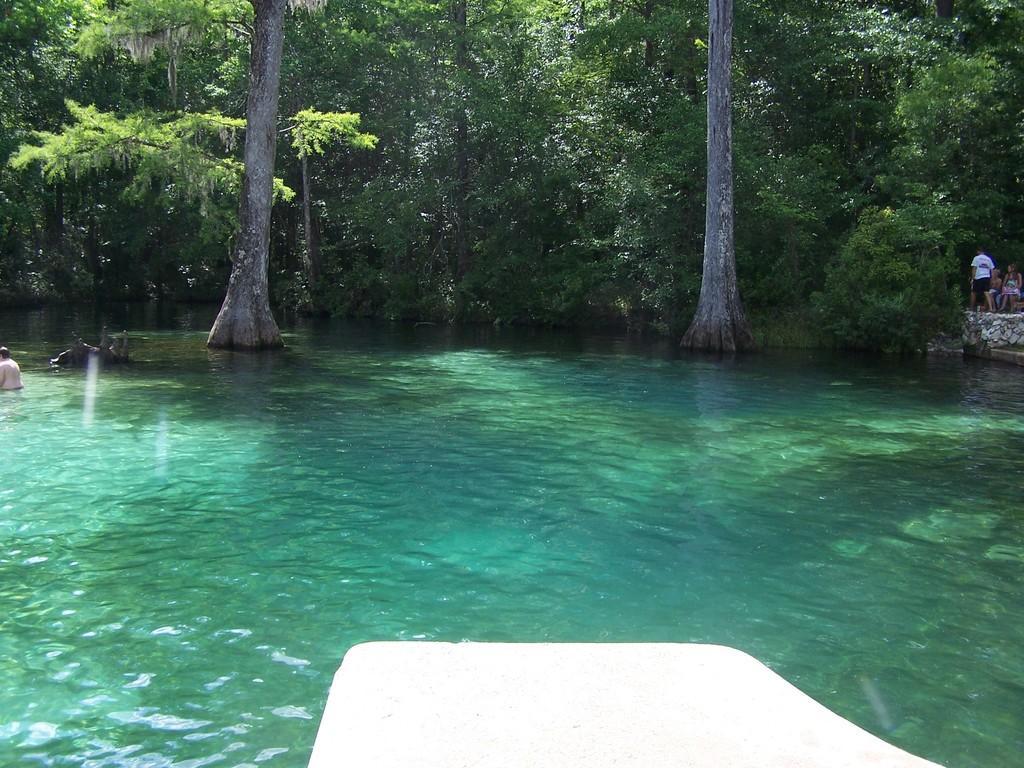How would you summarize this image in a sentence or two? In this image on the water body few people are swimming. In the background there are trees and few people. 